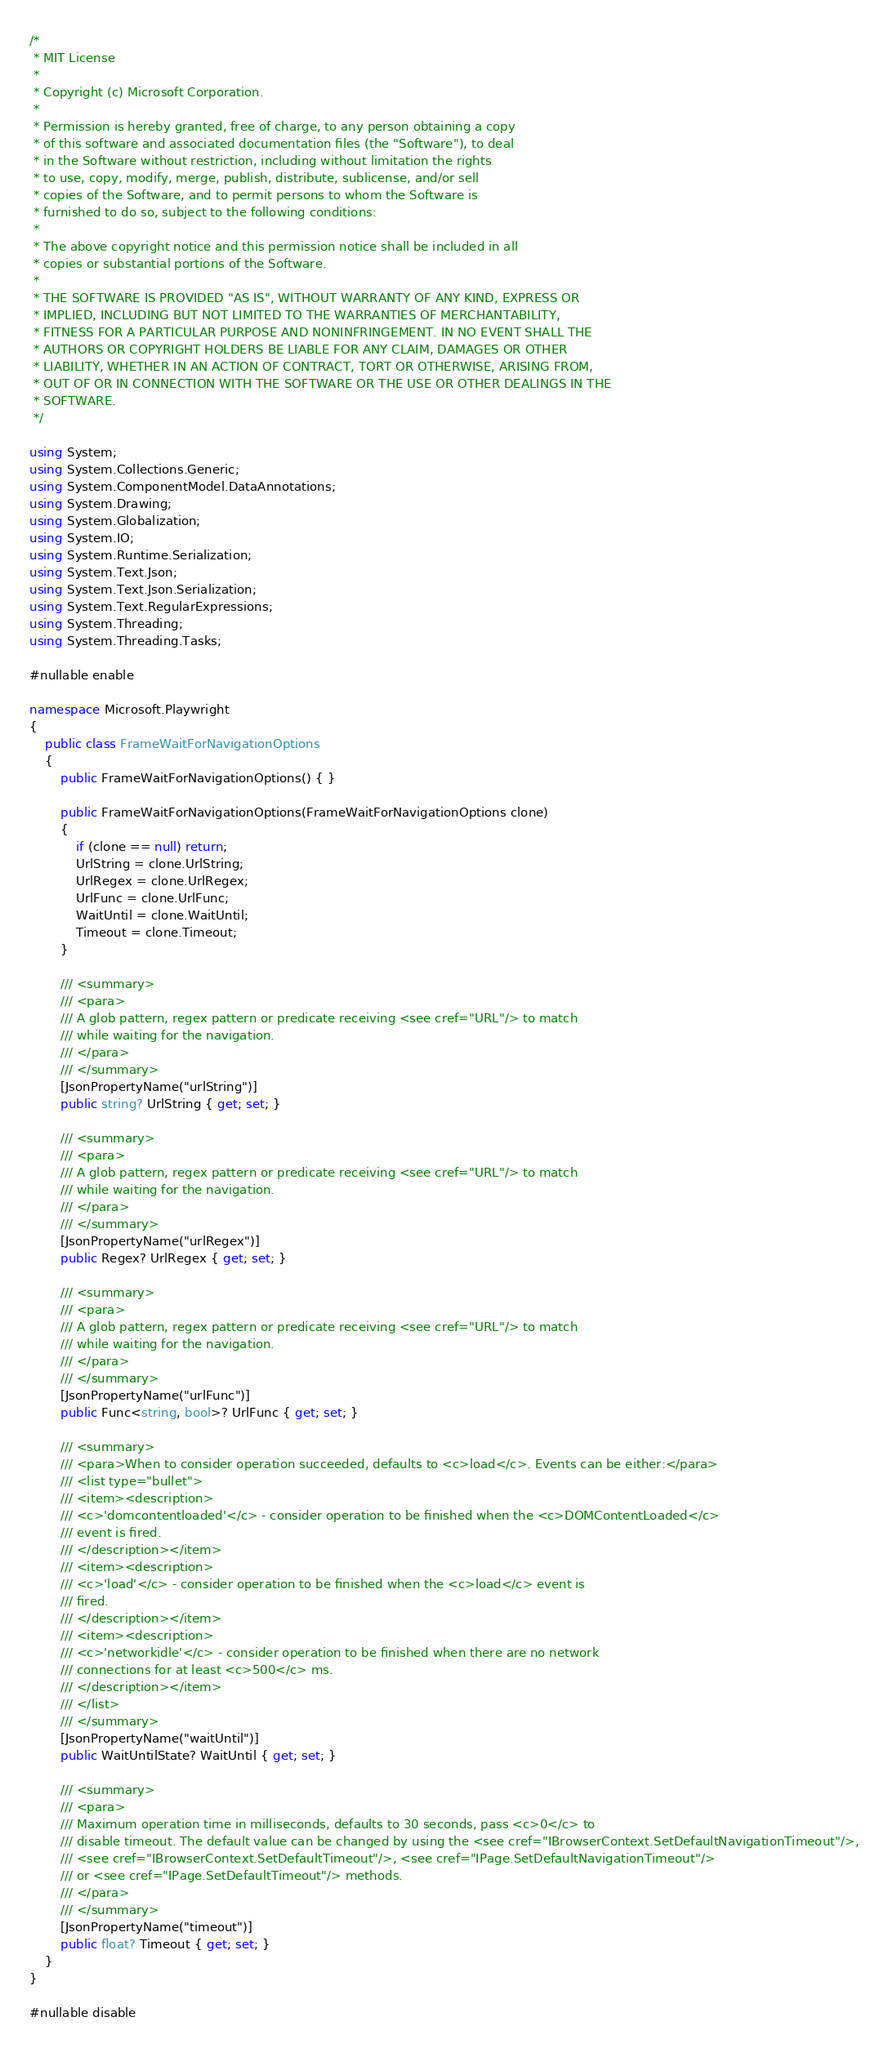<code> <loc_0><loc_0><loc_500><loc_500><_C#_>/*
 * MIT License
 *
 * Copyright (c) Microsoft Corporation.
 *
 * Permission is hereby granted, free of charge, to any person obtaining a copy
 * of this software and associated documentation files (the "Software"), to deal
 * in the Software without restriction, including without limitation the rights
 * to use, copy, modify, merge, publish, distribute, sublicense, and/or sell
 * copies of the Software, and to permit persons to whom the Software is
 * furnished to do so, subject to the following conditions:
 *
 * The above copyright notice and this permission notice shall be included in all
 * copies or substantial portions of the Software.
 *
 * THE SOFTWARE IS PROVIDED "AS IS", WITHOUT WARRANTY OF ANY KIND, EXPRESS OR
 * IMPLIED, INCLUDING BUT NOT LIMITED TO THE WARRANTIES OF MERCHANTABILITY,
 * FITNESS FOR A PARTICULAR PURPOSE AND NONINFRINGEMENT. IN NO EVENT SHALL THE
 * AUTHORS OR COPYRIGHT HOLDERS BE LIABLE FOR ANY CLAIM, DAMAGES OR OTHER
 * LIABILITY, WHETHER IN AN ACTION OF CONTRACT, TORT OR OTHERWISE, ARISING FROM,
 * OUT OF OR IN CONNECTION WITH THE SOFTWARE OR THE USE OR OTHER DEALINGS IN THE
 * SOFTWARE.
 */

using System;
using System.Collections.Generic;
using System.ComponentModel.DataAnnotations;
using System.Drawing;
using System.Globalization;
using System.IO;
using System.Runtime.Serialization;
using System.Text.Json;
using System.Text.Json.Serialization;
using System.Text.RegularExpressions;
using System.Threading;
using System.Threading.Tasks;

#nullable enable

namespace Microsoft.Playwright
{
    public class FrameWaitForNavigationOptions
    {
        public FrameWaitForNavigationOptions() { }

        public FrameWaitForNavigationOptions(FrameWaitForNavigationOptions clone)
        {
            if (clone == null) return;
            UrlString = clone.UrlString;
            UrlRegex = clone.UrlRegex;
            UrlFunc = clone.UrlFunc;
            WaitUntil = clone.WaitUntil;
            Timeout = clone.Timeout;
        }

        /// <summary>
        /// <para>
        /// A glob pattern, regex pattern or predicate receiving <see cref="URL"/> to match
        /// while waiting for the navigation.
        /// </para>
        /// </summary>
        [JsonPropertyName("urlString")]
        public string? UrlString { get; set; }

        /// <summary>
        /// <para>
        /// A glob pattern, regex pattern or predicate receiving <see cref="URL"/> to match
        /// while waiting for the navigation.
        /// </para>
        /// </summary>
        [JsonPropertyName("urlRegex")]
        public Regex? UrlRegex { get; set; }

        /// <summary>
        /// <para>
        /// A glob pattern, regex pattern or predicate receiving <see cref="URL"/> to match
        /// while waiting for the navigation.
        /// </para>
        /// </summary>
        [JsonPropertyName("urlFunc")]
        public Func<string, bool>? UrlFunc { get; set; }

        /// <summary>
        /// <para>When to consider operation succeeded, defaults to <c>load</c>. Events can be either:</para>
        /// <list type="bullet">
        /// <item><description>
        /// <c>'domcontentloaded'</c> - consider operation to be finished when the <c>DOMContentLoaded</c>
        /// event is fired.
        /// </description></item>
        /// <item><description>
        /// <c>'load'</c> - consider operation to be finished when the <c>load</c> event is
        /// fired.
        /// </description></item>
        /// <item><description>
        /// <c>'networkidle'</c> - consider operation to be finished when there are no network
        /// connections for at least <c>500</c> ms.
        /// </description></item>
        /// </list>
        /// </summary>
        [JsonPropertyName("waitUntil")]
        public WaitUntilState? WaitUntil { get; set; }

        /// <summary>
        /// <para>
        /// Maximum operation time in milliseconds, defaults to 30 seconds, pass <c>0</c> to
        /// disable timeout. The default value can be changed by using the <see cref="IBrowserContext.SetDefaultNavigationTimeout"/>,
        /// <see cref="IBrowserContext.SetDefaultTimeout"/>, <see cref="IPage.SetDefaultNavigationTimeout"/>
        /// or <see cref="IPage.SetDefaultTimeout"/> methods.
        /// </para>
        /// </summary>
        [JsonPropertyName("timeout")]
        public float? Timeout { get; set; }
    }
}

#nullable disable
</code> 